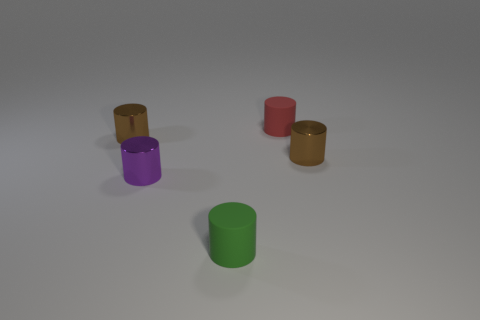What number of green things are big shiny things or rubber cylinders?
Give a very brief answer. 1. What is the material of the small cylinder that is in front of the small purple shiny cylinder?
Ensure brevity in your answer.  Rubber. Is the number of large blue rubber cylinders greater than the number of small green rubber objects?
Your answer should be compact. No. There is a brown thing left of the green matte thing; is its shape the same as the red matte thing?
Provide a succinct answer. Yes. What number of tiny cylinders are both in front of the small purple thing and behind the purple metal cylinder?
Offer a terse response. 0. What number of other green matte objects have the same shape as the small green matte object?
Your answer should be compact. 0. There is a rubber object that is behind the tiny green rubber thing right of the purple metallic object; what is its color?
Offer a very short reply. Red. Do the small red rubber thing and the green thing on the left side of the red matte cylinder have the same shape?
Keep it short and to the point. Yes. What material is the tiny brown object that is left of the tiny metal cylinder that is on the right side of the tiny matte cylinder left of the red rubber cylinder?
Your response must be concise. Metal. Are there any purple metallic cylinders of the same size as the red thing?
Make the answer very short. Yes. 